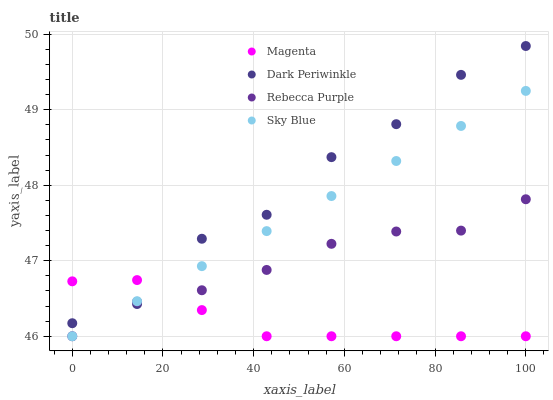Does Magenta have the minimum area under the curve?
Answer yes or no. Yes. Does Dark Periwinkle have the maximum area under the curve?
Answer yes or no. Yes. Does Dark Periwinkle have the minimum area under the curve?
Answer yes or no. No. Does Magenta have the maximum area under the curve?
Answer yes or no. No. Is Sky Blue the smoothest?
Answer yes or no. Yes. Is Dark Periwinkle the roughest?
Answer yes or no. Yes. Is Magenta the smoothest?
Answer yes or no. No. Is Magenta the roughest?
Answer yes or no. No. Does Sky Blue have the lowest value?
Answer yes or no. Yes. Does Dark Periwinkle have the lowest value?
Answer yes or no. No. Does Dark Periwinkle have the highest value?
Answer yes or no. Yes. Does Magenta have the highest value?
Answer yes or no. No. Does Sky Blue intersect Dark Periwinkle?
Answer yes or no. Yes. Is Sky Blue less than Dark Periwinkle?
Answer yes or no. No. Is Sky Blue greater than Dark Periwinkle?
Answer yes or no. No. 